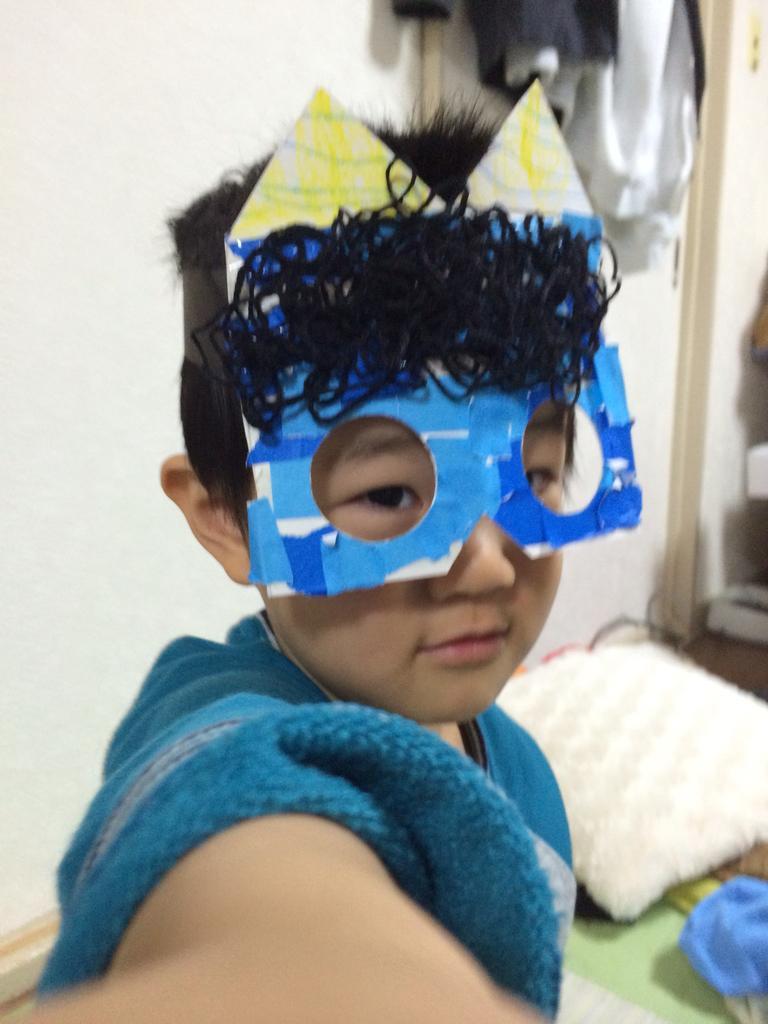Could you give a brief overview of what you see in this image? In this image we can see a boy wearing a mask, also we can see a pillow and some other objects, in the background we can see the wall and some clothes. 